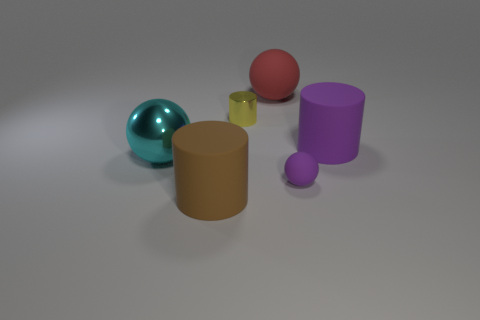Subtract all tiny yellow cylinders. How many cylinders are left? 2 Add 3 big gray metallic spheres. How many objects exist? 9 Subtract 1 spheres. How many spheres are left? 2 Subtract all yellow balls. Subtract all yellow cylinders. How many balls are left? 3 Add 2 cyan cubes. How many cyan cubes exist? 2 Subtract 1 purple cylinders. How many objects are left? 5 Subtract all cyan shiny balls. Subtract all green spheres. How many objects are left? 5 Add 5 tiny purple rubber things. How many tiny purple rubber things are left? 6 